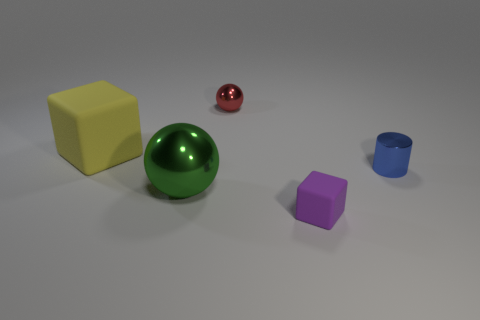Add 3 blue objects. How many objects exist? 8 Subtract 1 spheres. How many spheres are left? 1 Subtract all green spheres. How many spheres are left? 1 Subtract all blocks. How many objects are left? 3 Subtract 0 yellow balls. How many objects are left? 5 Subtract all yellow blocks. Subtract all brown cylinders. How many blocks are left? 1 Subtract all blue balls. How many yellow cubes are left? 1 Subtract all small gray spheres. Subtract all tiny purple objects. How many objects are left? 4 Add 3 blue cylinders. How many blue cylinders are left? 4 Add 5 purple rubber objects. How many purple rubber objects exist? 6 